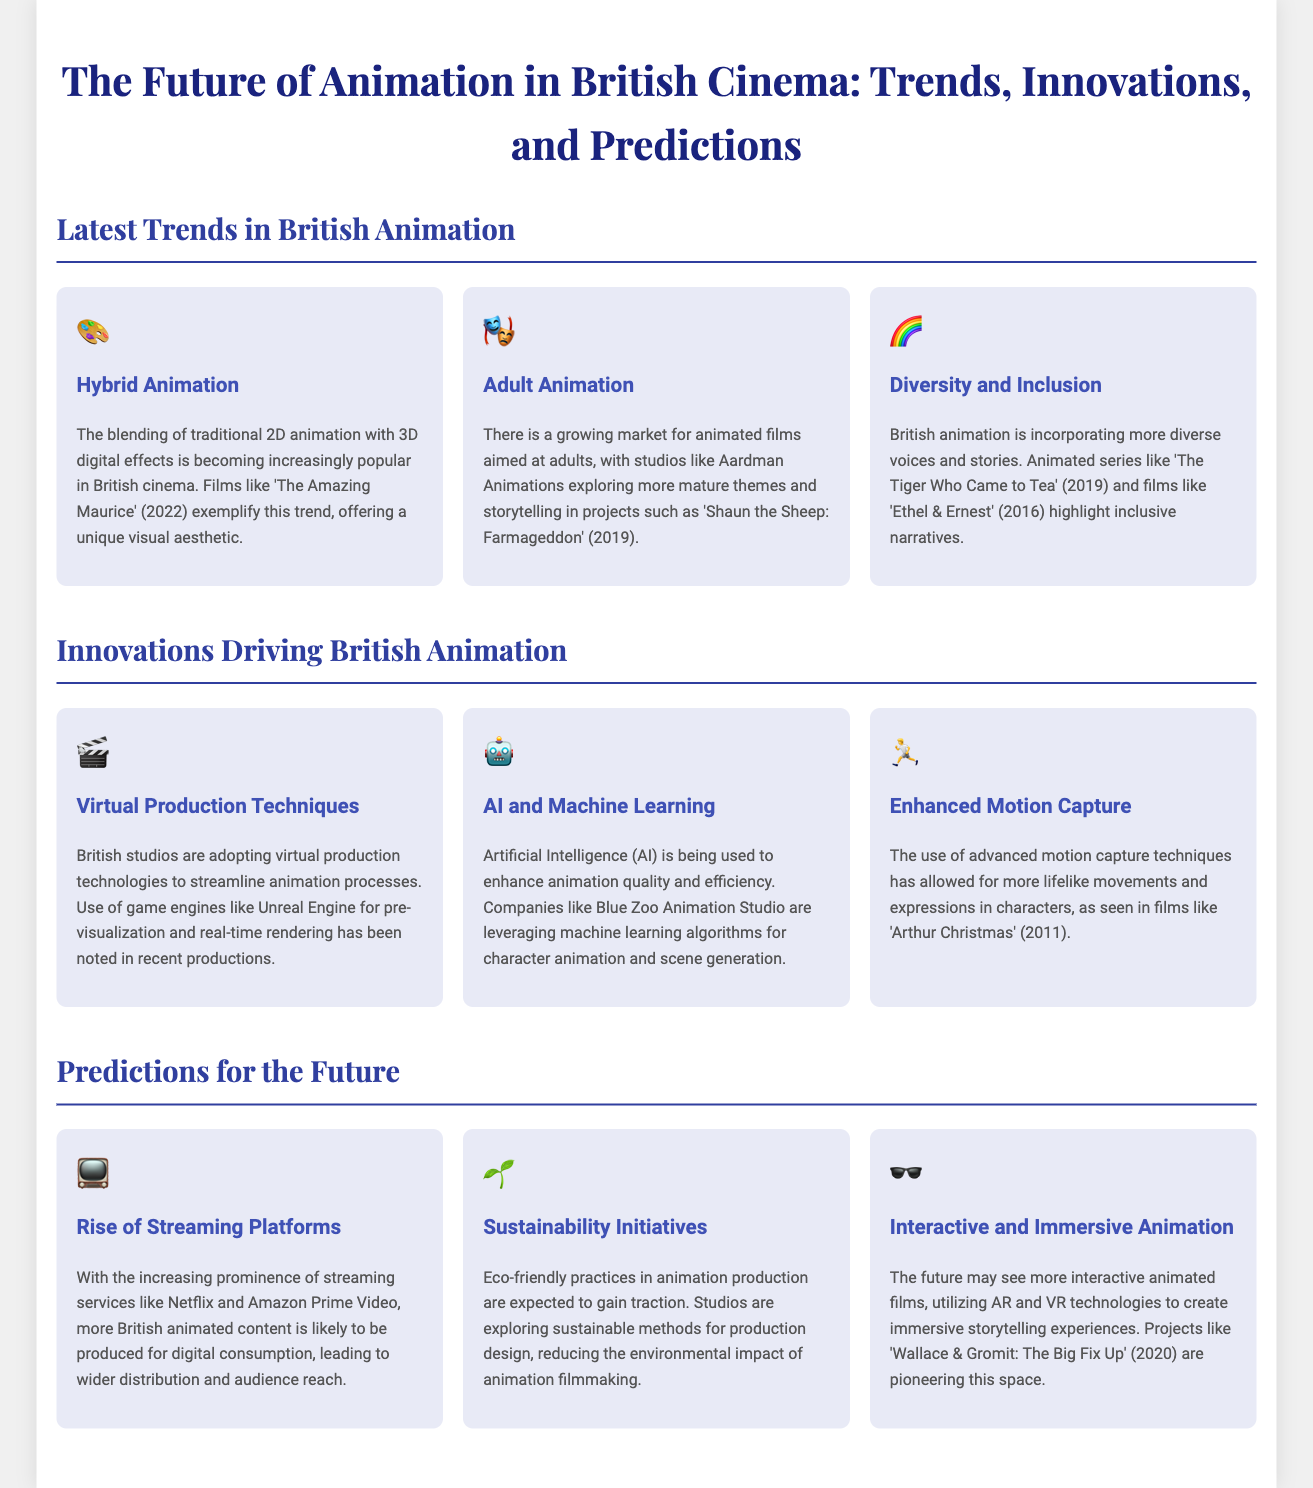what is one example of hybrid animation mentioned in the document? The document cites 'The Amazing Maurice' (2022) as an example of hybrid animation, which blends traditional 2D animation with 3D digital effects.
Answer: 'The Amazing Maurice' (2022) which studio is known for exploring more mature themes in animation? Aardman Animations is mentioned as a studio that explores more mature themes in animated projects.
Answer: Aardman Animations what technology is being used for pre-visualization in British animation studios? The document indicates that game engines like Unreal Engine are being used for pre-visualization in British animation.
Answer: Unreal Engine how has animation in British cinema changed in terms of diversity? The document explains that British animation is incorporating more diverse voices and stories, as seen in series like 'The Tiger Who Came to Tea' (2019).
Answer: more diverse voices and stories what do experts predict about the future of streaming platforms? The document predicts that more British animated content is likely to be produced for digital consumption due to the prominence of streaming services.
Answer: more British animated content what immersive technologies are mentioned in relation to future animation projects? The document mentions AR and VR technologies as immersive technologies likely to be utilized in future animated films.
Answer: AR and VR technologies 